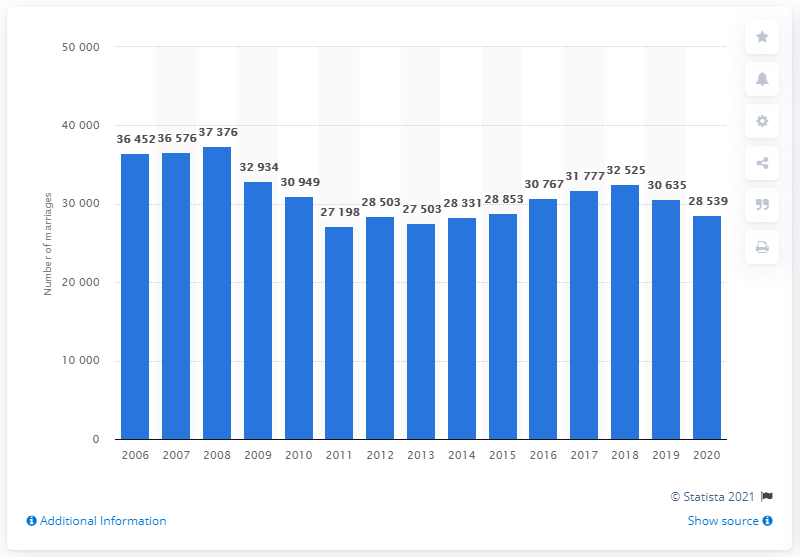Point out several critical features in this image. In 2011, a total of 27,198 marriages were registered in Denmark. In 2020, a total of 28,539 marriages were registered in Denmark. 